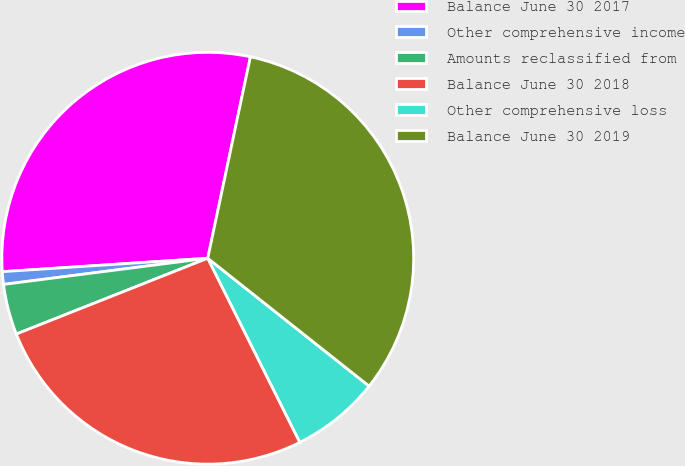<chart> <loc_0><loc_0><loc_500><loc_500><pie_chart><fcel>Balance June 30 2017<fcel>Other comprehensive income<fcel>Amounts reclassified from<fcel>Balance June 30 2018<fcel>Other comprehensive loss<fcel>Balance June 30 2019<nl><fcel>29.36%<fcel>0.99%<fcel>3.97%<fcel>26.38%<fcel>6.95%<fcel>32.34%<nl></chart> 